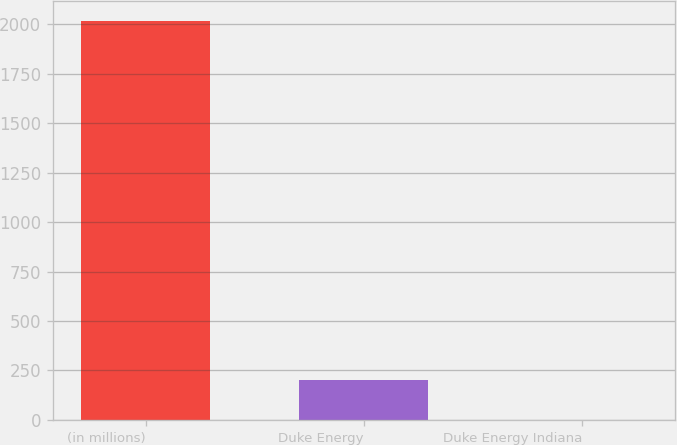Convert chart. <chart><loc_0><loc_0><loc_500><loc_500><bar_chart><fcel>(in millions)<fcel>Duke Energy<fcel>Duke Energy Indiana<nl><fcel>2015<fcel>202.4<fcel>1<nl></chart> 